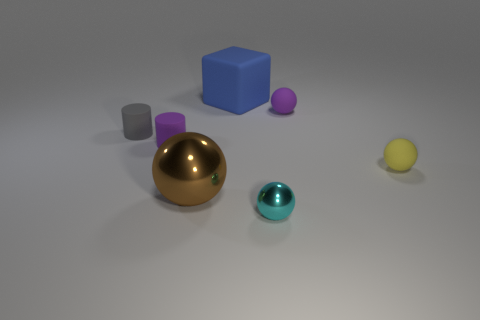What number of other tiny cyan metal things are the same shape as the small metal object?
Give a very brief answer. 0. Are there the same number of metallic things that are in front of the rubber block and big blue rubber cubes?
Offer a very short reply. No. Is there anything else that is the same size as the yellow matte sphere?
Your answer should be compact. Yes. What is the shape of the gray object that is the same size as the cyan object?
Provide a short and direct response. Cylinder. Are there any other tiny gray matte things that have the same shape as the tiny gray matte object?
Offer a terse response. No. Is there a small yellow matte ball behind the rubber sphere that is to the right of the small purple matte object that is to the right of the brown metallic sphere?
Provide a short and direct response. No. Is the number of small cylinders in front of the large brown metallic object greater than the number of blue cubes behind the cyan sphere?
Your answer should be compact. No. There is a purple cylinder that is the same size as the cyan ball; what material is it?
Your answer should be compact. Rubber. How many large objects are brown balls or yellow cubes?
Your answer should be very brief. 1. Is the shape of the big brown metallic object the same as the large rubber object?
Provide a short and direct response. No. 